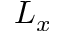Convert formula to latex. <formula><loc_0><loc_0><loc_500><loc_500>L _ { x }</formula> 